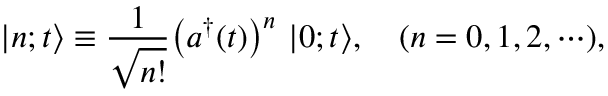Convert formula to latex. <formula><loc_0><loc_0><loc_500><loc_500>| n ; t \Big > \equiv \frac { 1 } { \sqrt { n ! } } \left ( a ^ { \dagger } ( t ) \right ) ^ { n } | 0 ; t \Big > , ( n = 0 , 1 , 2 , \cdots ) ,</formula> 